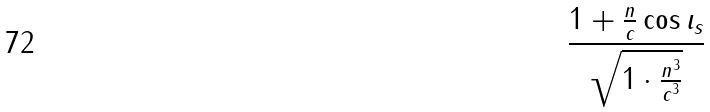<formula> <loc_0><loc_0><loc_500><loc_500>\frac { 1 + \frac { n } { c } \cos \iota _ { s } } { \sqrt { 1 \cdot \frac { n ^ { 3 } } { c ^ { 3 } } } }</formula> 